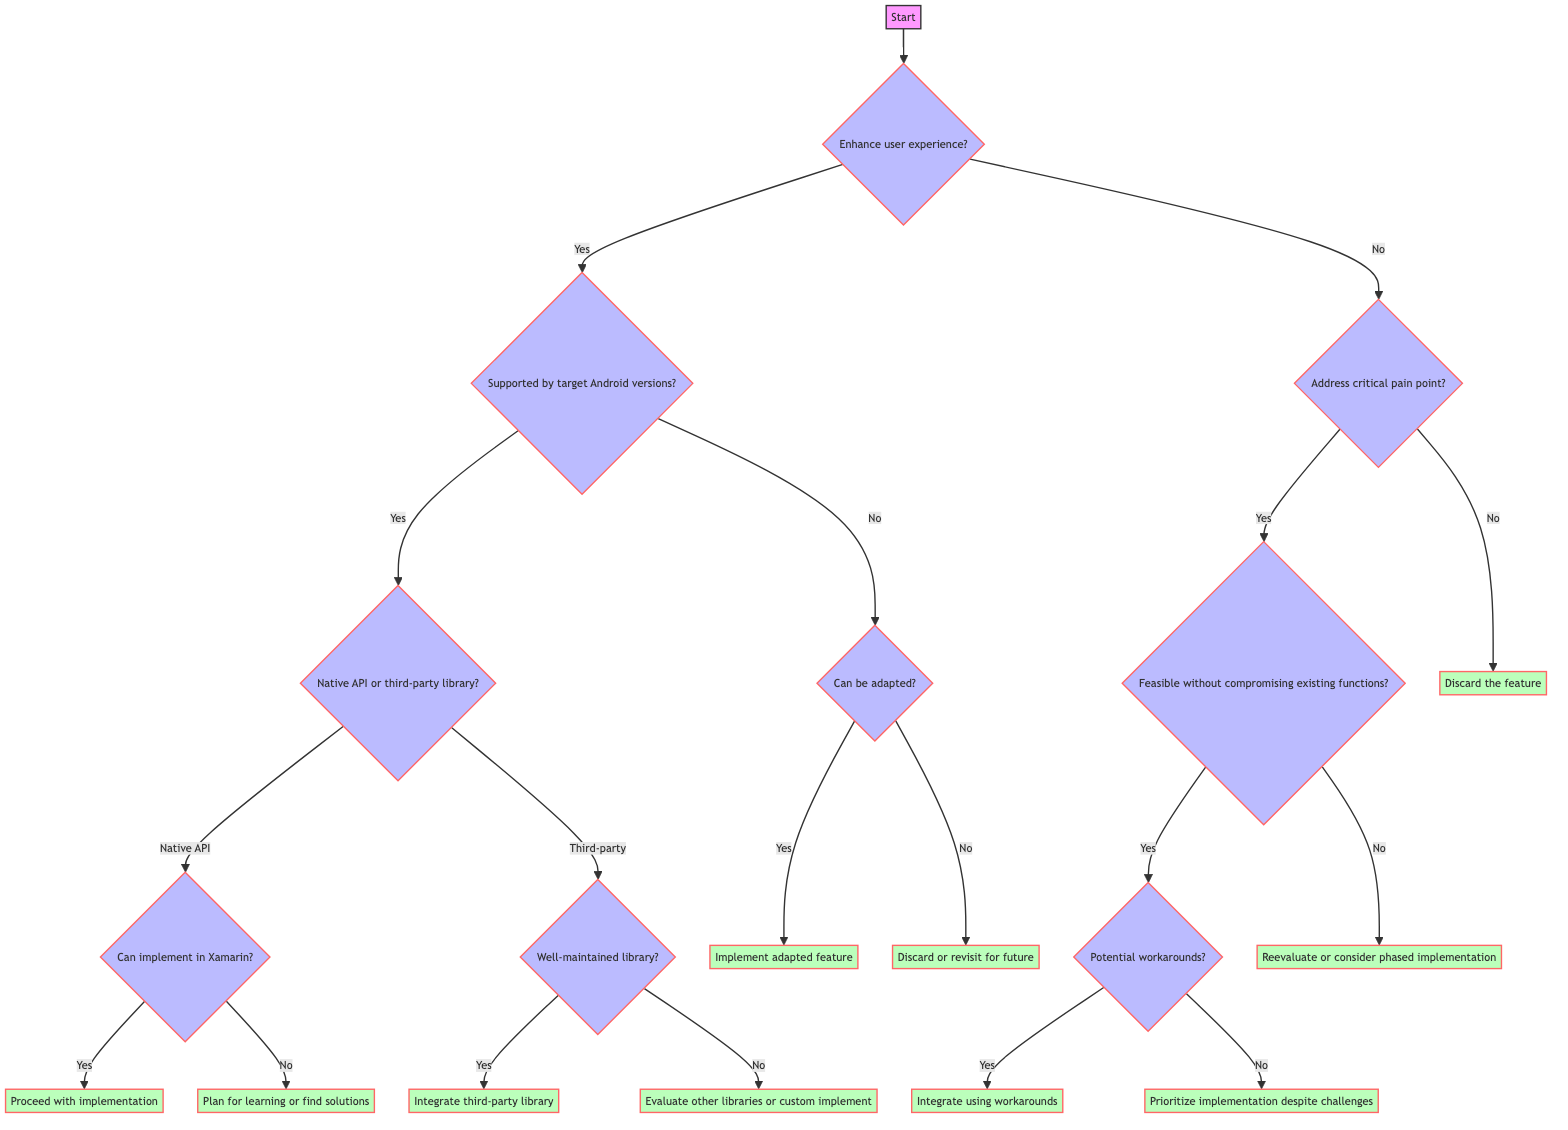What is the first decision in the flowchart? The first decision in the flowchart is whether the feature enhances user experience.
Answer: Enhance user experience? What action is taken if the feature is supported by target Android versions? If the feature is supported by target Android versions, it leads to determining if there is native API support or a third-party library available.
Answer: Determine API/library support What happens if there is a well-maintained third-party library? If there is a well-maintained third-party library, the action taken is to integrate the third-party library in Xamarin.
Answer: Integrate third-party library How many main paths are there after determining if the feature enhances user experience? There are two main paths after this decision: one for if the answer is yes and another for if it's no.
Answer: Two What should be done if the feature does not enhance user experience and does address a critical pain point? If the feature does not enhance user experience but does address a critical pain point, the next step is to check if it is feasible to implement without compromising existing functionalities.
Answer: Check feasibility What is the final action if potential workarounds exist after determining feasibility? If potential workarounds exist, the final action is to integrate the feature using those workarounds or alternatives.
Answer: Integrate using workarounds What happens if the feature can be adapted to work within supported versions? If the feature can be adapted to work within supported versions, the action taken is to implement the adapted feature.
Answer: Implement adapted feature What criteria follows if the feature does not enhance user experience and does not address a critical pain point? If the feature does not enhance user experience and does not address a critical pain point, the next action is to discard the feature.
Answer: Discard the feature What must be assessed if the feature can be adapted after it is not supported by target Android versions? If the feature can be adapted, it leads to the action of implementing the adapted feature.
Answer: Implement adapted feature 